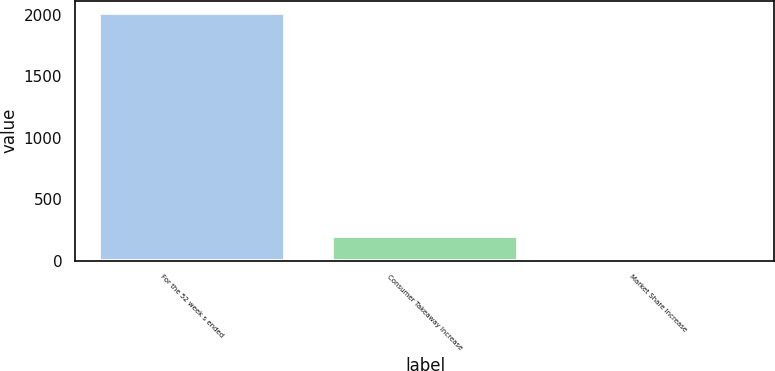<chart> <loc_0><loc_0><loc_500><loc_500><bar_chart><fcel>For the 52 week s ended<fcel>Consumer Takeaway Increase<fcel>Market Share Increase<nl><fcel>2011<fcel>201.82<fcel>0.8<nl></chart> 